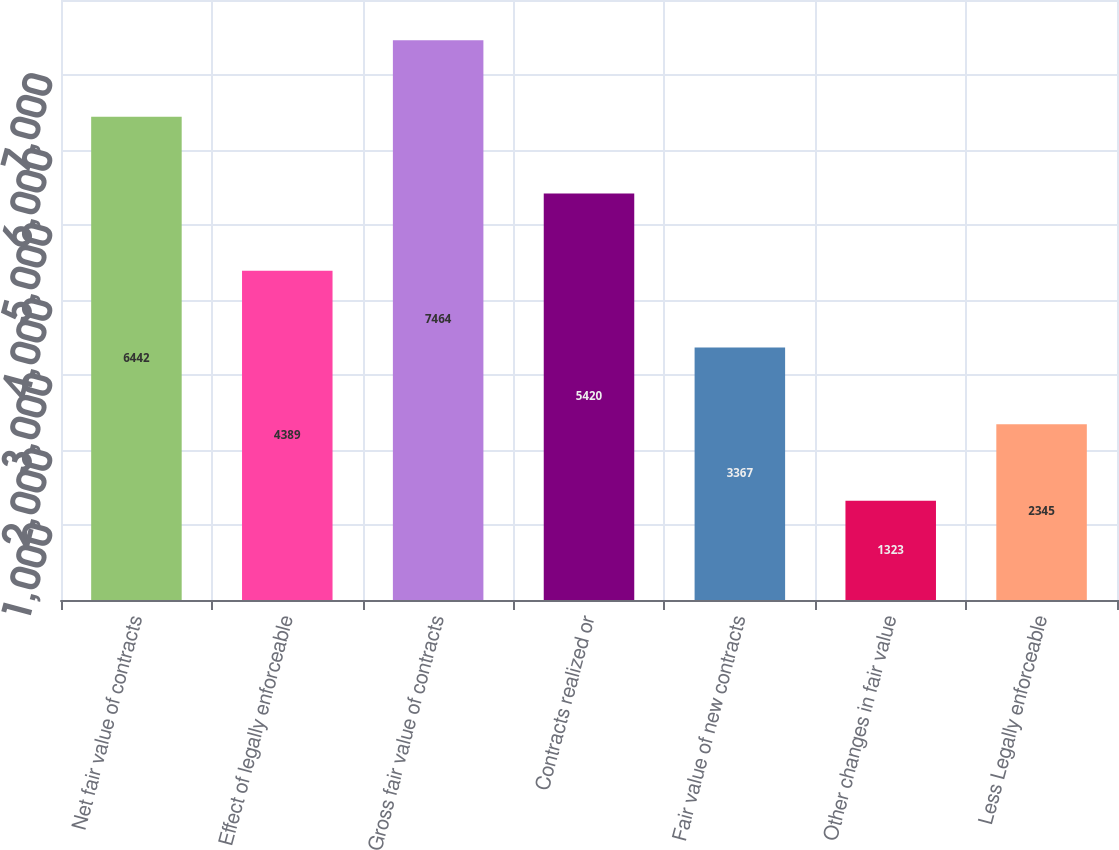Convert chart to OTSL. <chart><loc_0><loc_0><loc_500><loc_500><bar_chart><fcel>Net fair value of contracts<fcel>Effect of legally enforceable<fcel>Gross fair value of contracts<fcel>Contracts realized or<fcel>Fair value of new contracts<fcel>Other changes in fair value<fcel>Less Legally enforceable<nl><fcel>6442<fcel>4389<fcel>7464<fcel>5420<fcel>3367<fcel>1323<fcel>2345<nl></chart> 